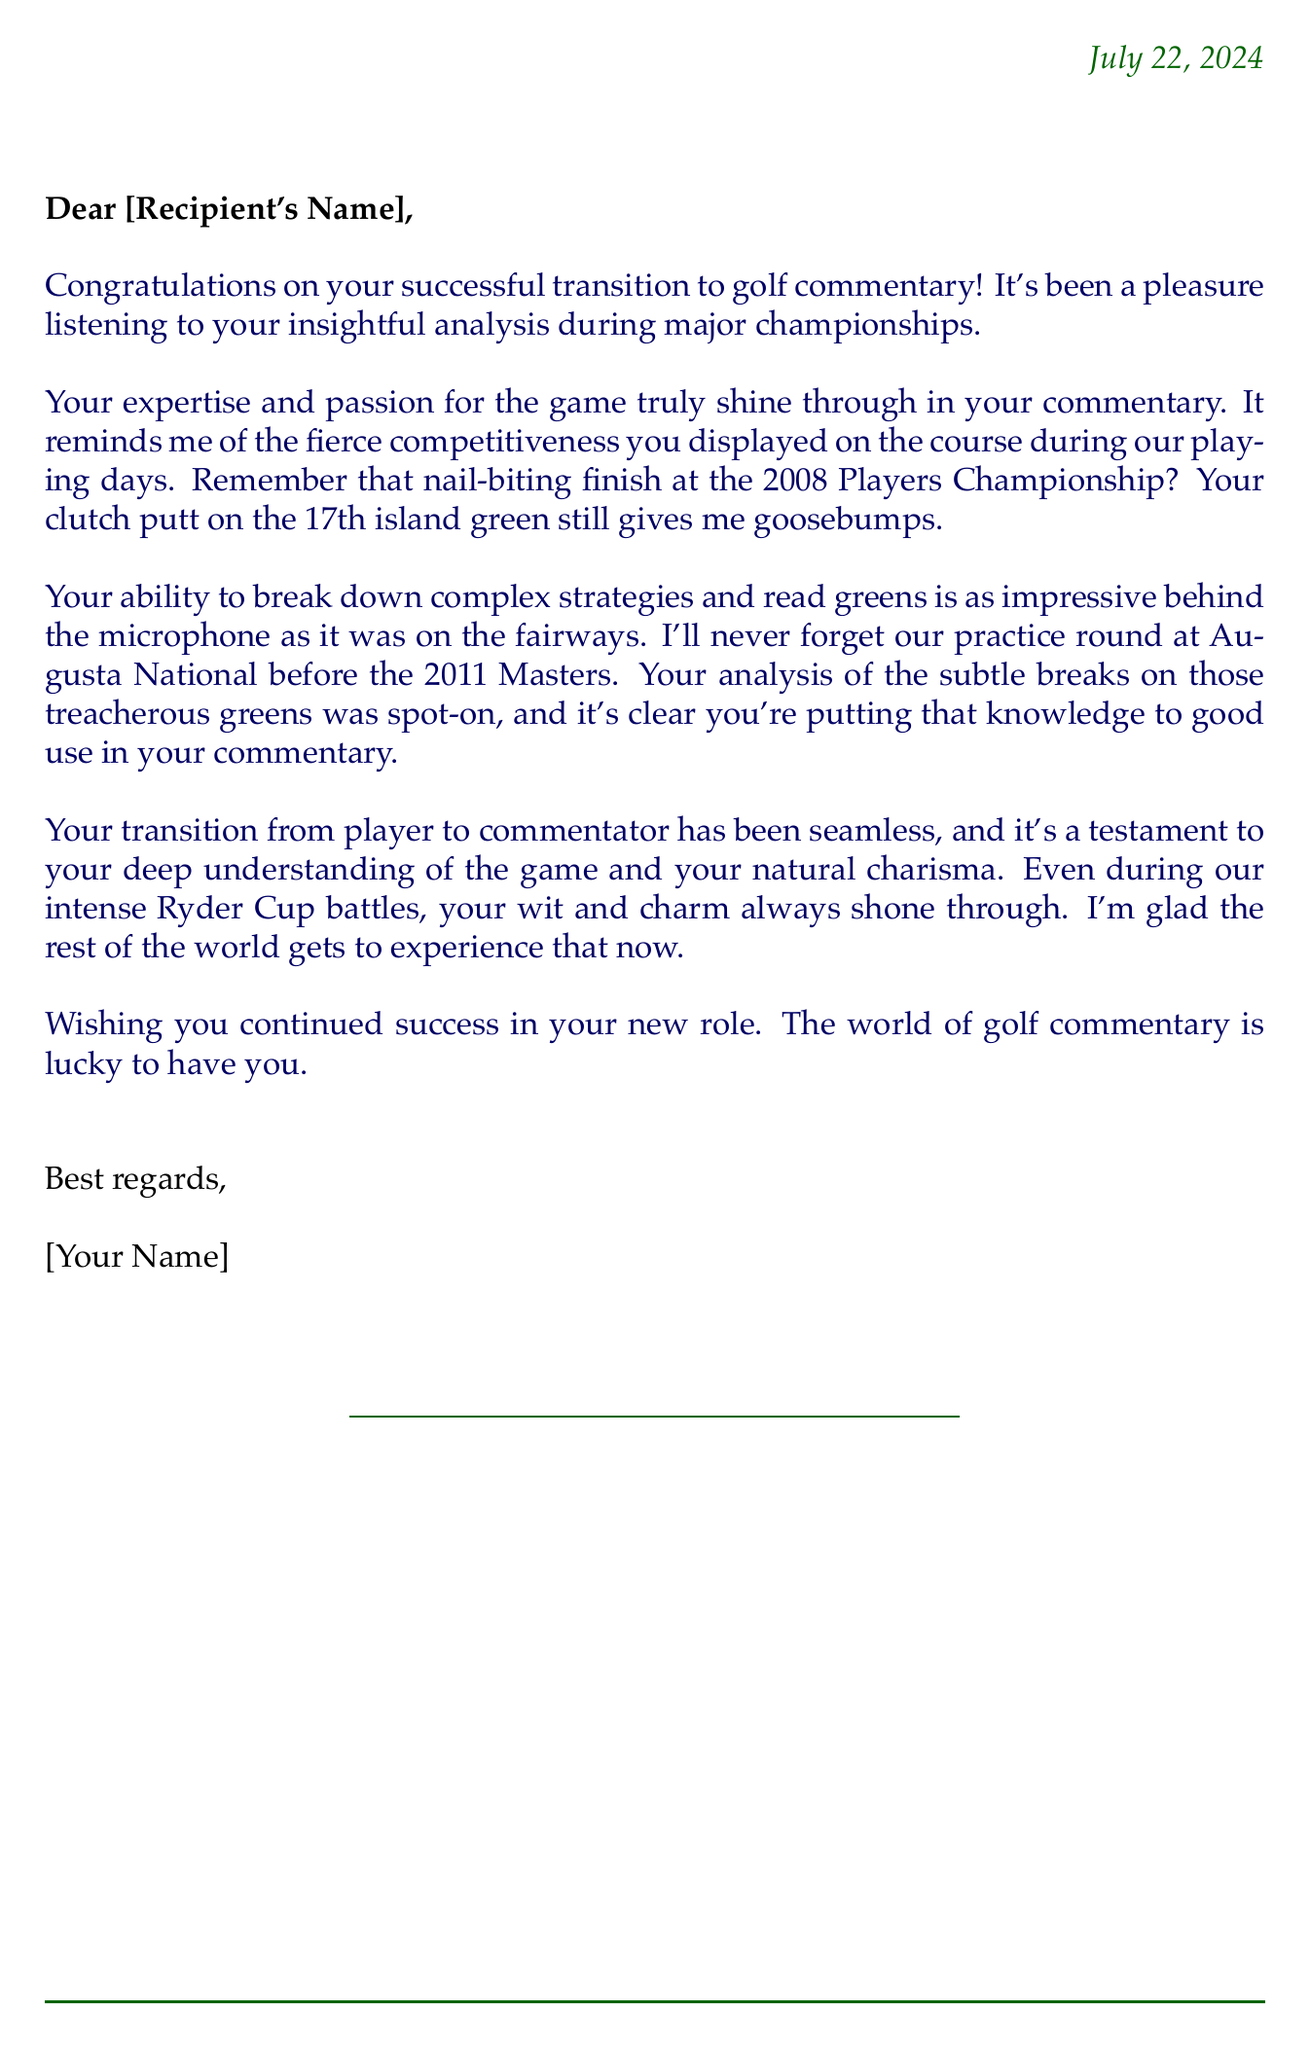What is the recipient's name? The letter does not specify the recipient's name, but it's addressed to "[Recipient's Name]."
Answer: [Recipient's Name] What event is mentioned in the first anecdote? The first anecdote refers to a specific golf tournament, which is the 2008 Players Championship.
Answer: 2008 Players Championship Which golf course is mentioned in the second anecdote? The second anecdote references the famous golf course where the practice round took place, which is Augusta National.
Answer: Augusta National What year did the Masters tournament referenced take place? The letter mentions a practice round before the 2011 Masters, indicating the year of the tournament.
Answer: 2011 Who wrote the letter? The signature section indicates that the letter is signed by "[Your Name]."
Answer: [Your Name] What key quality is highlighted about the transition from player to commentator? The letter describes the transition as "seamless," indicating a smooth change from one role to another.
Answer: seamless What characteristic of the commentary is specifically praised? The commentary is noted for its "insightful analysis," highlighting the depth of insight provided.
Answer: insightful analysis What is the closing wish expressed in the letter? The author wishes the recipient "continued success" in their new role.
Answer: continued success 